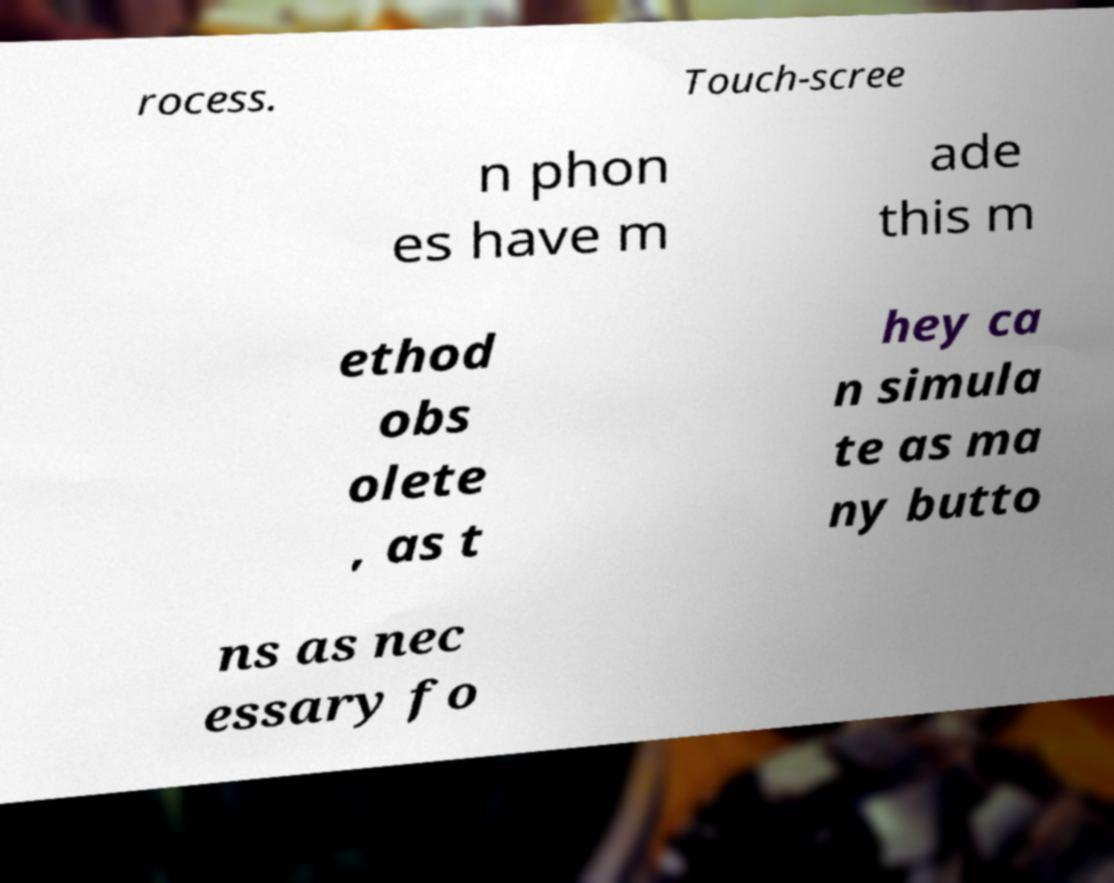There's text embedded in this image that I need extracted. Can you transcribe it verbatim? rocess. Touch-scree n phon es have m ade this m ethod obs olete , as t hey ca n simula te as ma ny butto ns as nec essary fo 